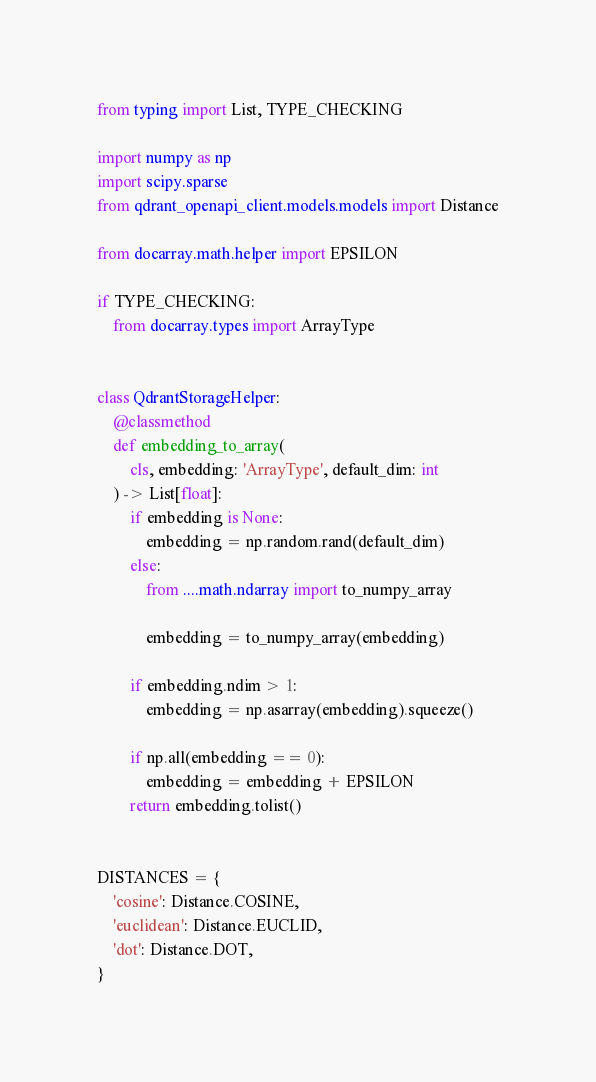<code> <loc_0><loc_0><loc_500><loc_500><_Python_>from typing import List, TYPE_CHECKING

import numpy as np
import scipy.sparse
from qdrant_openapi_client.models.models import Distance

from docarray.math.helper import EPSILON

if TYPE_CHECKING:
    from docarray.types import ArrayType


class QdrantStorageHelper:
    @classmethod
    def embedding_to_array(
        cls, embedding: 'ArrayType', default_dim: int
    ) -> List[float]:
        if embedding is None:
            embedding = np.random.rand(default_dim)
        else:
            from ....math.ndarray import to_numpy_array

            embedding = to_numpy_array(embedding)

        if embedding.ndim > 1:
            embedding = np.asarray(embedding).squeeze()

        if np.all(embedding == 0):
            embedding = embedding + EPSILON
        return embedding.tolist()


DISTANCES = {
    'cosine': Distance.COSINE,
    'euclidean': Distance.EUCLID,
    'dot': Distance.DOT,
}
</code> 